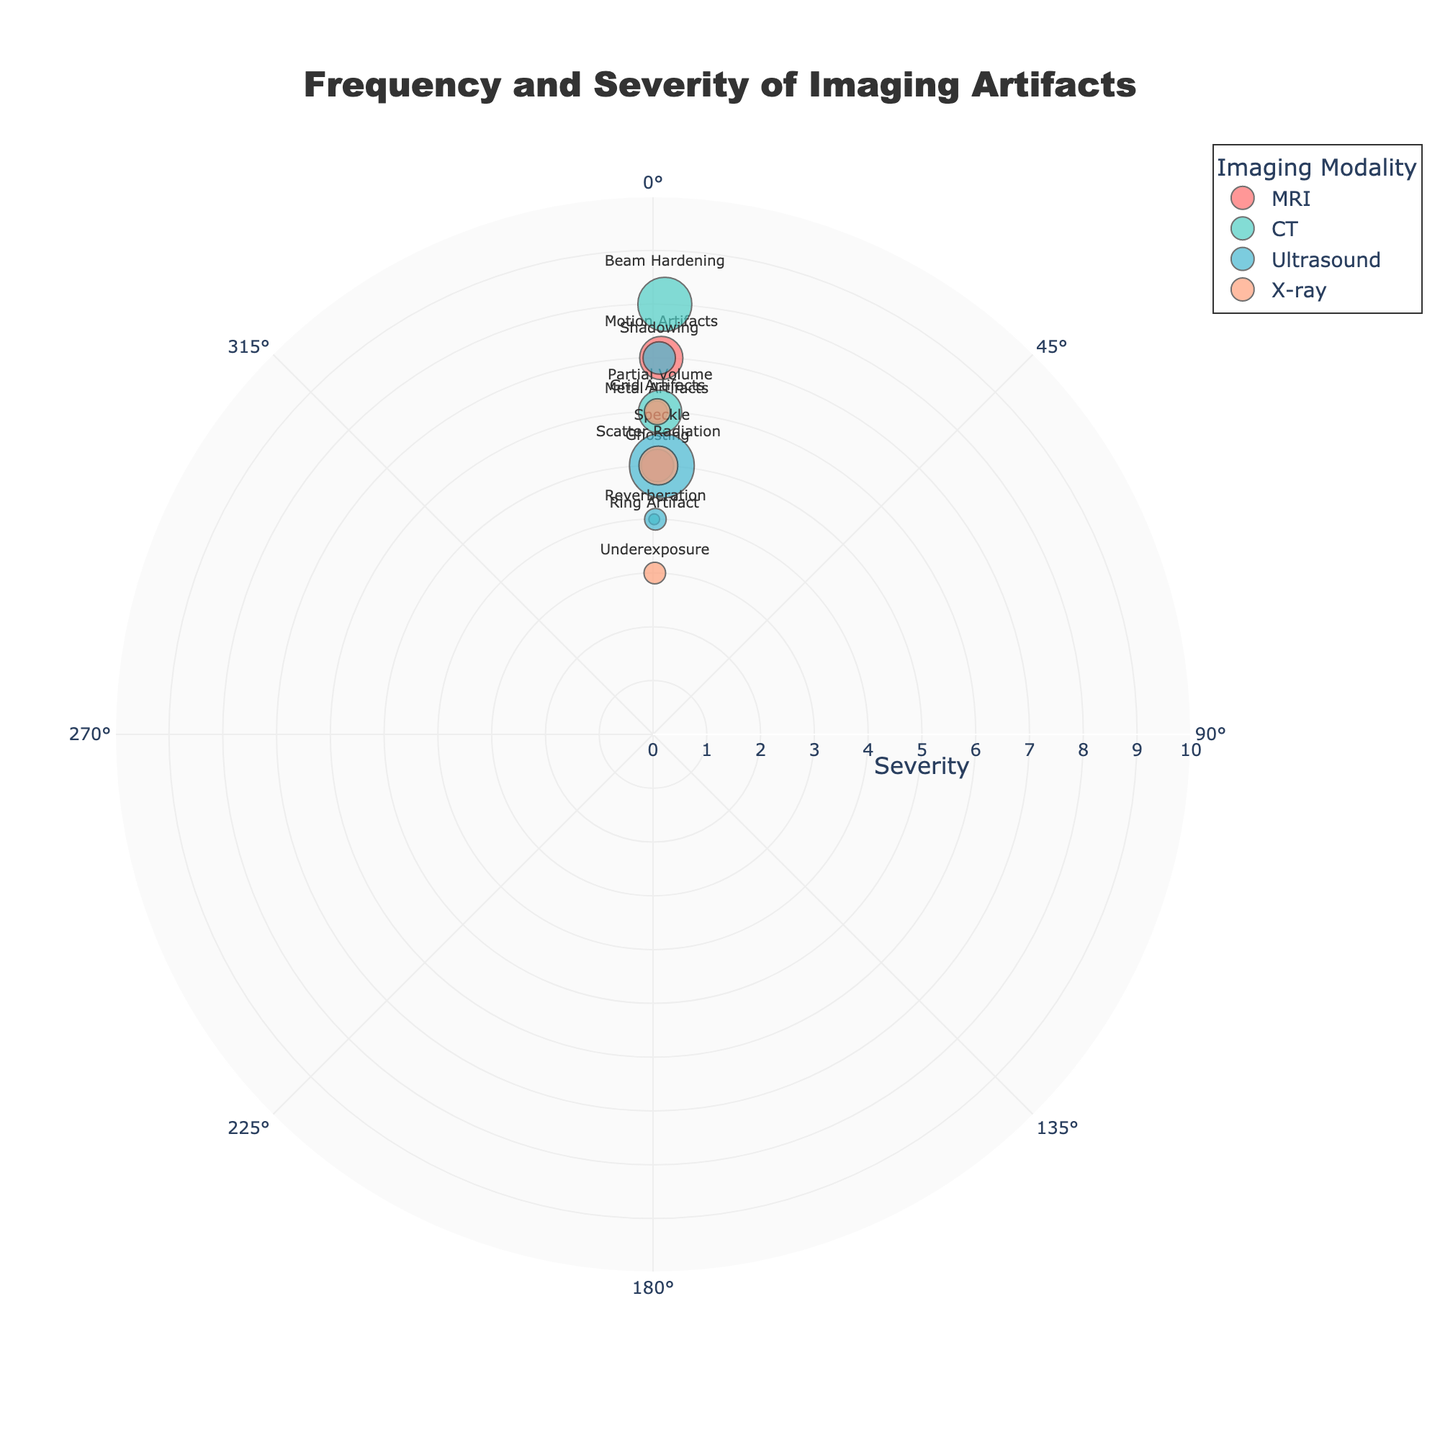What's the title of the figure? The title of the figure is displayed prominently at the top of the chart. It reads "Frequency and Severity of Imaging Artifacts" as per the layout configuration defined in the code.
Answer: Frequency and Severity of Imaging Artifacts What is represented on the radial axis? The radial axis of the polar scatter chart represents the severity of the imaging artifacts, with values ranging from 0 to 10. This is indicated in the layout of the chart.
Answer: Severity Which imaging artifact has the highest frequency? By inspecting the size of the markers and hovering over the points to see the frequencies, the artifact "Speckle" in Ultrasound shows a frequency of 30 per 100, the highest in the dataset.
Answer: Speckle Which imaging modality has the lowest number of artifacts listed? By counting the data points for each imaging modality, X-ray has only three markers (points). Thus, it has the lowest number of artifacts listed.
Answer: X-ray What is the severity of the "Beam Hardening" artifact in CT modality? By finding the "Beam Hardening" artifact marker within the CT modality portion of the chart, hovering reveals the severity value, which is 8.
Answer: 8 Compare the frequencies of "Reverberation" in Ultrasound and "Motion Artifacts" in MRI. How do they differ? "Reverberation" in Ultrasound has a frequency of 10 per 100, whereas "Motion Artifacts" in MRI has a frequency of 20 per 100. The difference in their frequencies is 20 - 10 = 10.
Answer: 10 Which artifact has the highest severity but a frequency less than 20 per 100? By examining the severity values and checking the frequencies, "Beam Hardening" in CT has a severity of 8 and a frequency of 25. But "Motion Artifacts" in MRI, with severity 7 and frequency 20 fits, hence it is not less than 20. So the answer would be "Metal Artifacts" in MRI with a severity of 6 and a frequency of 10.
Answer: Metal Artifacts in MRI Which artifact in the MRI modality has the lowest severity? By inspecting the markers labeled under MRI and comparing their severities, the "Ghosting" artifact has the lowest severity value of 5.
Answer: Ghosting What is the average severity of artifacts in the CT modality? The severities for CT are Beam Hardening (8), Partial Volume (6), and Ring Artifact (4). Average severity = (8 + 6 + 4) / 3 = 18 / 3 = 6.
Answer: 6 Which modality has an artifact with the largest marker size? The size of the markers reflects the frequency of the artifacts. As per the data, the largest marker size corresponds to the "Speckle" artifact in Ultrasound with a frequency of 30 per 100. Thus, Ultrasound has the artifact with the largest marker size.
Answer: Ultrasound 